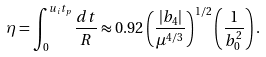<formula> <loc_0><loc_0><loc_500><loc_500>\eta = \int _ { 0 } ^ { u _ { i } t _ { p } } \frac { d t } { R } \approx 0 . 9 2 \left ( \frac { | b _ { 4 } | } { \mu ^ { 4 / 3 } } \right ) ^ { 1 / 2 } \left ( \frac { 1 } { b _ { 0 } ^ { 2 } } \right ) .</formula> 